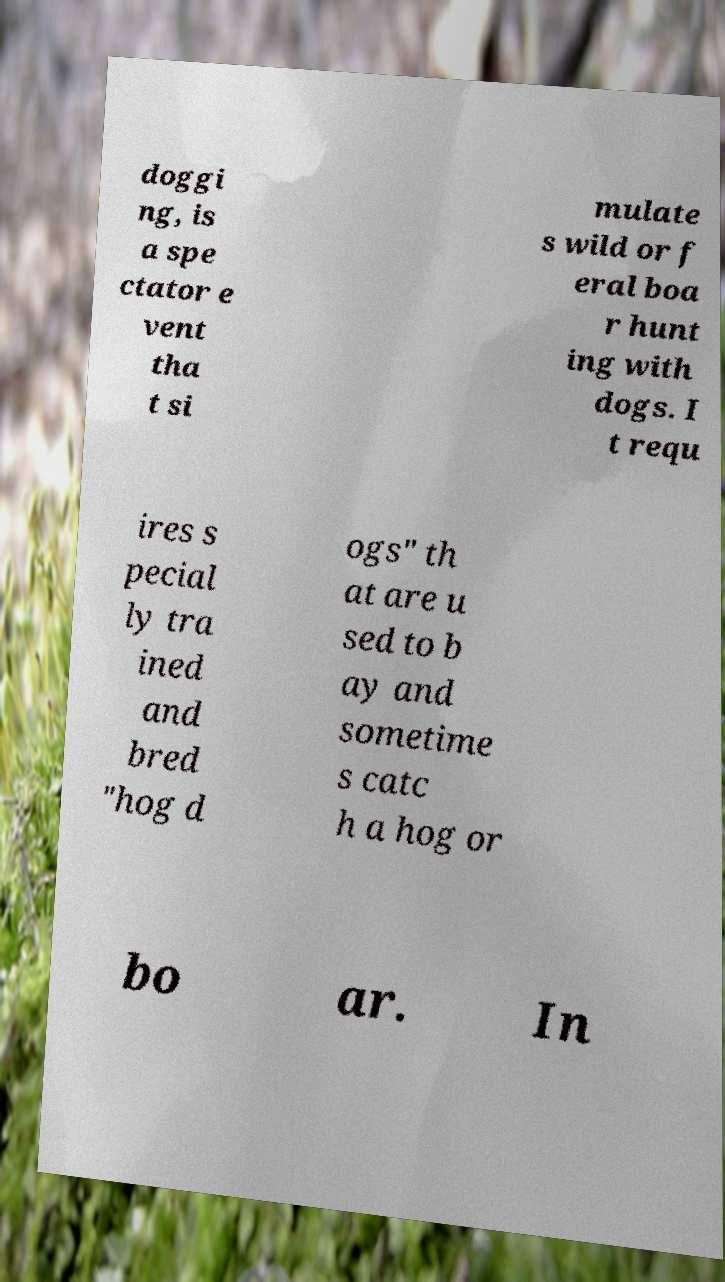Please read and relay the text visible in this image. What does it say? doggi ng, is a spe ctator e vent tha t si mulate s wild or f eral boa r hunt ing with dogs. I t requ ires s pecial ly tra ined and bred "hog d ogs" th at are u sed to b ay and sometime s catc h a hog or bo ar. In 